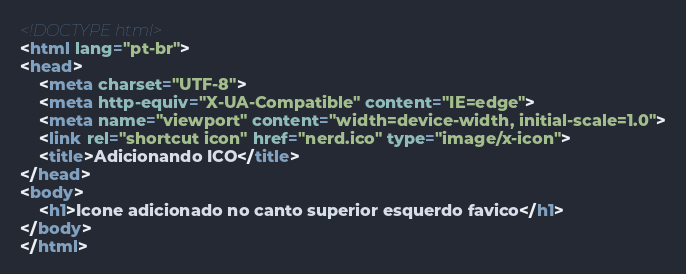Convert code to text. <code><loc_0><loc_0><loc_500><loc_500><_HTML_><!DOCTYPE html>
<html lang="pt-br">
<head>
    <meta charset="UTF-8">
    <meta http-equiv="X-UA-Compatible" content="IE=edge">
    <meta name="viewport" content="width=device-width, initial-scale=1.0">
    <link rel="shortcut icon" href="nerd.ico" type="image/x-icon">
    <title>Adicionando ICO</title>
</head>
<body>
    <h1>Icone adicionado no canto superior esquerdo favico</h1>
</body>
</html></code> 